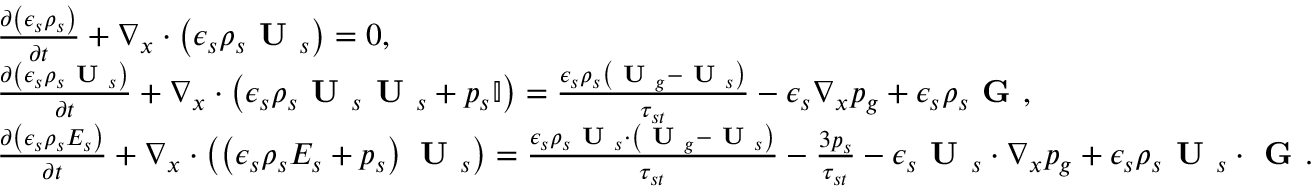Convert formula to latex. <formula><loc_0><loc_0><loc_500><loc_500>\begin{array} { r l } & { \frac { \partial \left ( \epsilon _ { s } \rho _ { s } \right ) } { \partial t } + \nabla _ { x } \cdot \left ( \epsilon _ { s } \rho _ { s } U _ { s } \right ) = 0 , } \\ & { \frac { \partial \left ( \epsilon _ { s } \rho _ { s } U _ { s } \right ) } { \partial t } + \nabla _ { x } \cdot \left ( \epsilon _ { s } \rho _ { s } U _ { s } U _ { s } + p _ { s } \mathbb { I } \right ) = \frac { \epsilon _ { s } \rho _ { s } \left ( U _ { g } - U _ { s } \right ) } { \tau _ { s t } } - \epsilon _ { s } \nabla _ { x } p _ { g } + \epsilon _ { s } \rho _ { s } G , } \\ & { \frac { \partial \left ( \epsilon _ { s } \rho _ { s } E _ { s } \right ) } { \partial t } + \nabla _ { x } \cdot \left ( \left ( \epsilon _ { s } \rho _ { s } E _ { s } + p _ { s } \right ) U _ { s } \right ) = \frac { \epsilon _ { s } \rho _ { s } U _ { s } \cdot \left ( U _ { g } - U _ { s } \right ) } { \tau _ { s t } } - \frac { 3 p _ { s } } { \tau _ { s t } } - \epsilon _ { s } U _ { s } \cdot \nabla _ { x } p _ { g } + \epsilon _ { s } \rho _ { s } U _ { s } \cdot G . } \end{array}</formula> 